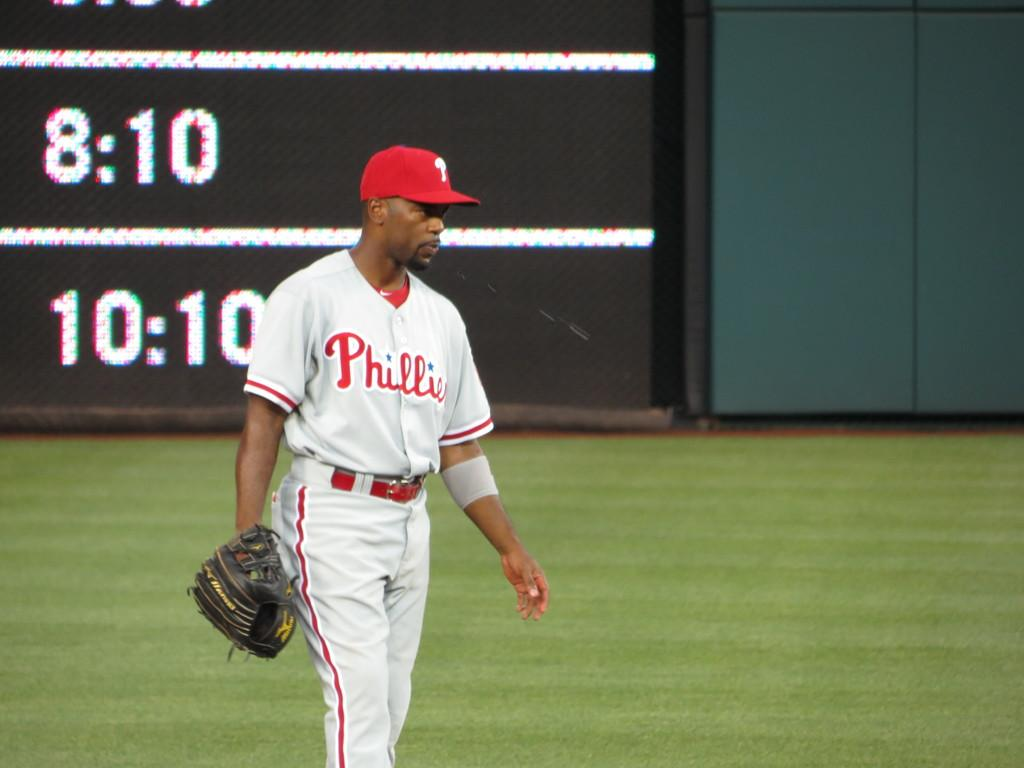<image>
Present a compact description of the photo's key features. A baseball player wearing a white Phillies jersey. 